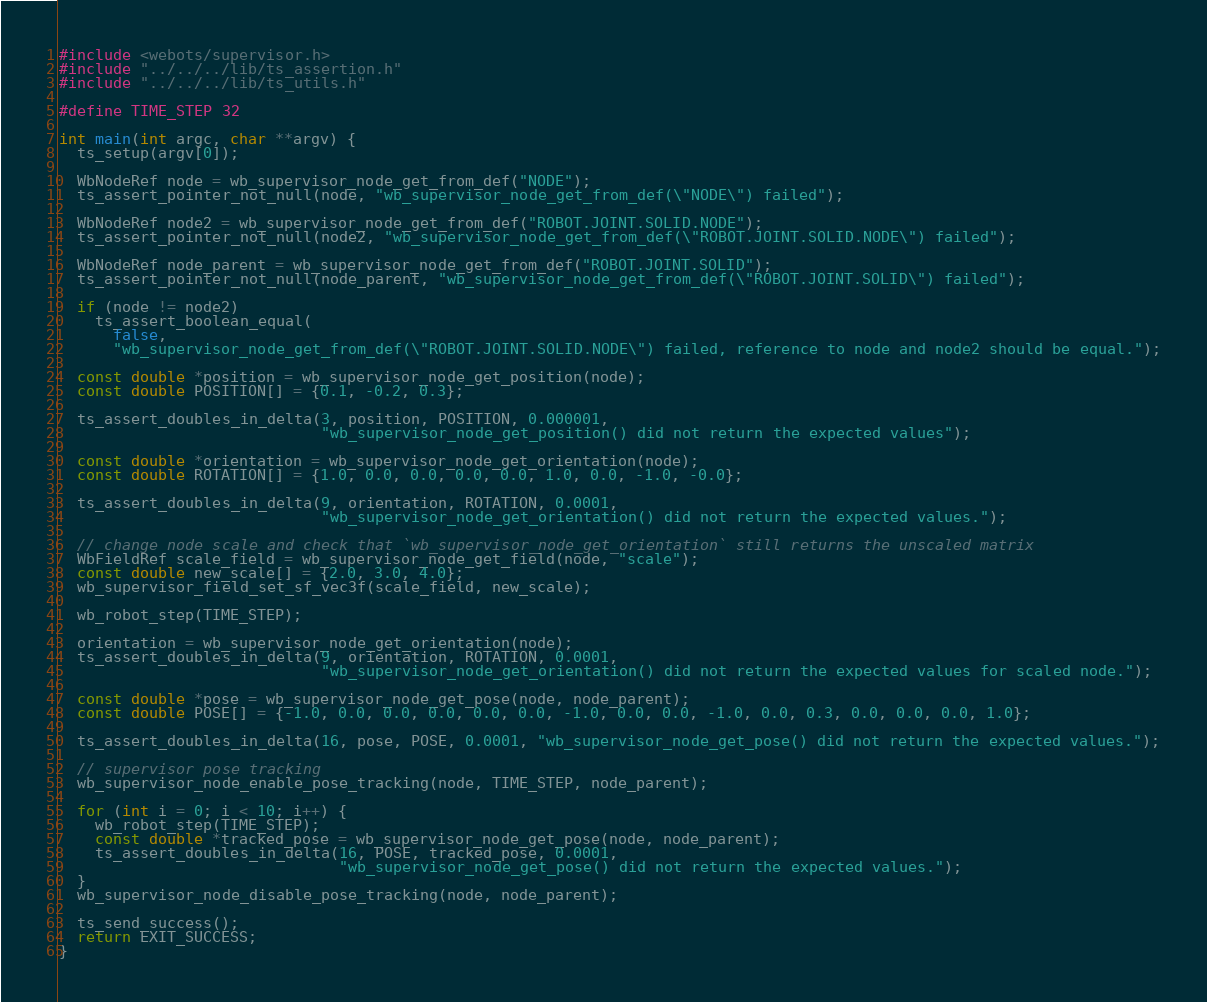<code> <loc_0><loc_0><loc_500><loc_500><_C_>#include <webots/supervisor.h>
#include "../../../lib/ts_assertion.h"
#include "../../../lib/ts_utils.h"

#define TIME_STEP 32

int main(int argc, char **argv) {
  ts_setup(argv[0]);

  WbNodeRef node = wb_supervisor_node_get_from_def("NODE");
  ts_assert_pointer_not_null(node, "wb_supervisor_node_get_from_def(\"NODE\") failed");

  WbNodeRef node2 = wb_supervisor_node_get_from_def("ROBOT.JOINT.SOLID.NODE");
  ts_assert_pointer_not_null(node2, "wb_supervisor_node_get_from_def(\"ROBOT.JOINT.SOLID.NODE\") failed");

  WbNodeRef node_parent = wb_supervisor_node_get_from_def("ROBOT.JOINT.SOLID");
  ts_assert_pointer_not_null(node_parent, "wb_supervisor_node_get_from_def(\"ROBOT.JOINT.SOLID\") failed");

  if (node != node2)
    ts_assert_boolean_equal(
      false,
      "wb_supervisor_node_get_from_def(\"ROBOT.JOINT.SOLID.NODE\") failed, reference to node and node2 should be equal.");

  const double *position = wb_supervisor_node_get_position(node);
  const double POSITION[] = {0.1, -0.2, 0.3};

  ts_assert_doubles_in_delta(3, position, POSITION, 0.000001,
                             "wb_supervisor_node_get_position() did not return the expected values");

  const double *orientation = wb_supervisor_node_get_orientation(node);
  const double ROTATION[] = {1.0, 0.0, 0.0, 0.0, 0.0, 1.0, 0.0, -1.0, -0.0};

  ts_assert_doubles_in_delta(9, orientation, ROTATION, 0.0001,
                             "wb_supervisor_node_get_orientation() did not return the expected values.");

  // change node scale and check that `wb_supervisor_node_get_orientation` still returns the unscaled matrix
  WbFieldRef scale_field = wb_supervisor_node_get_field(node, "scale");
  const double new_scale[] = {2.0, 3.0, 4.0};
  wb_supervisor_field_set_sf_vec3f(scale_field, new_scale);

  wb_robot_step(TIME_STEP);

  orientation = wb_supervisor_node_get_orientation(node);
  ts_assert_doubles_in_delta(9, orientation, ROTATION, 0.0001,
                             "wb_supervisor_node_get_orientation() did not return the expected values for scaled node.");

  const double *pose = wb_supervisor_node_get_pose(node, node_parent);
  const double POSE[] = {-1.0, 0.0, 0.0, 0.0, 0.0, 0.0, -1.0, 0.0, 0.0, -1.0, 0.0, 0.3, 0.0, 0.0, 0.0, 1.0};

  ts_assert_doubles_in_delta(16, pose, POSE, 0.0001, "wb_supervisor_node_get_pose() did not return the expected values.");

  // supervisor pose tracking
  wb_supervisor_node_enable_pose_tracking(node, TIME_STEP, node_parent);

  for (int i = 0; i < 10; i++) {
    wb_robot_step(TIME_STEP);
    const double *tracked_pose = wb_supervisor_node_get_pose(node, node_parent);
    ts_assert_doubles_in_delta(16, POSE, tracked_pose, 0.0001,
                               "wb_supervisor_node_get_pose() did not return the expected values.");
  }
  wb_supervisor_node_disable_pose_tracking(node, node_parent);

  ts_send_success();
  return EXIT_SUCCESS;
}
</code> 